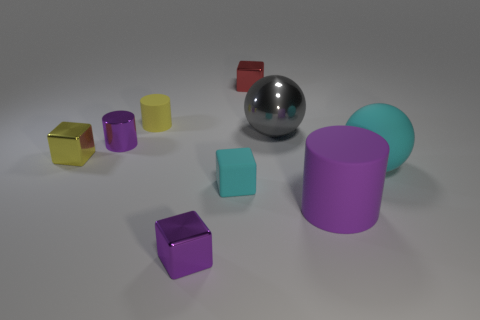Can you tell me which objects are closest to the silver sphere? The golden cube and the dark purple block are the closest objects to the silver sphere. 